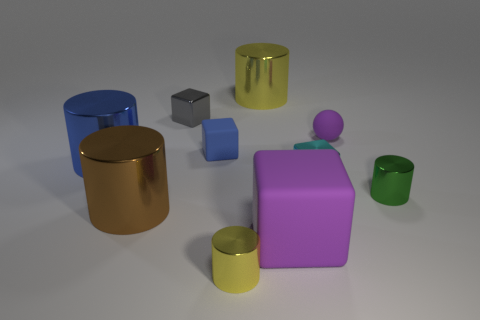There is a large object that is behind the small ball; is it the same color as the small metallic cylinder that is in front of the green metal object?
Ensure brevity in your answer.  Yes. There is a big metal cylinder that is on the left side of the brown cylinder; is it the same color as the small rubber cube?
Your response must be concise. Yes. The small object that is both in front of the cyan cube and right of the big matte thing is made of what material?
Make the answer very short. Metal. Is there a blue shiny object that has the same size as the brown metal object?
Offer a very short reply. Yes. How many yellow metal things are there?
Give a very brief answer. 2. What number of tiny metal things are on the left side of the cyan block?
Your answer should be compact. 2. Are the cyan thing and the tiny green cylinder made of the same material?
Your answer should be compact. Yes. How many tiny metallic objects are on the right side of the small gray metal object and behind the blue cube?
Provide a succinct answer. 0. How many other objects are there of the same color as the large rubber thing?
Your response must be concise. 1. How many cyan objects are cylinders or cubes?
Offer a very short reply. 1. 